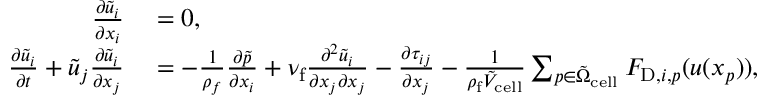Convert formula to latex. <formula><loc_0><loc_0><loc_500><loc_500>\begin{array} { r l } { \frac { \partial \tilde { u } _ { i } } { \partial x _ { i } } } & = 0 , } \\ { \frac { \partial \tilde { u } _ { i } } { \partial t } + \tilde { u } _ { j } \frac { \partial \tilde { u } _ { i } } { \partial x _ { j } } } & = - \frac { 1 } { \rho _ { f } } \frac { \partial \tilde { p } } { \partial x _ { i } } + \nu _ { f } \frac { \partial ^ { 2 } \tilde { u } _ { i } } { \partial x _ { j } \partial x _ { j } } - \frac { \partial \tau _ { i j } } { \partial x _ { j } } - \frac { 1 } { \rho _ { f } \tilde { V } _ { c e l l } } \sum _ { p \in \tilde { \Omega } _ { c e l l } } F _ { D , i , p } ( u ( x _ { p } ) ) , } \end{array}</formula> 